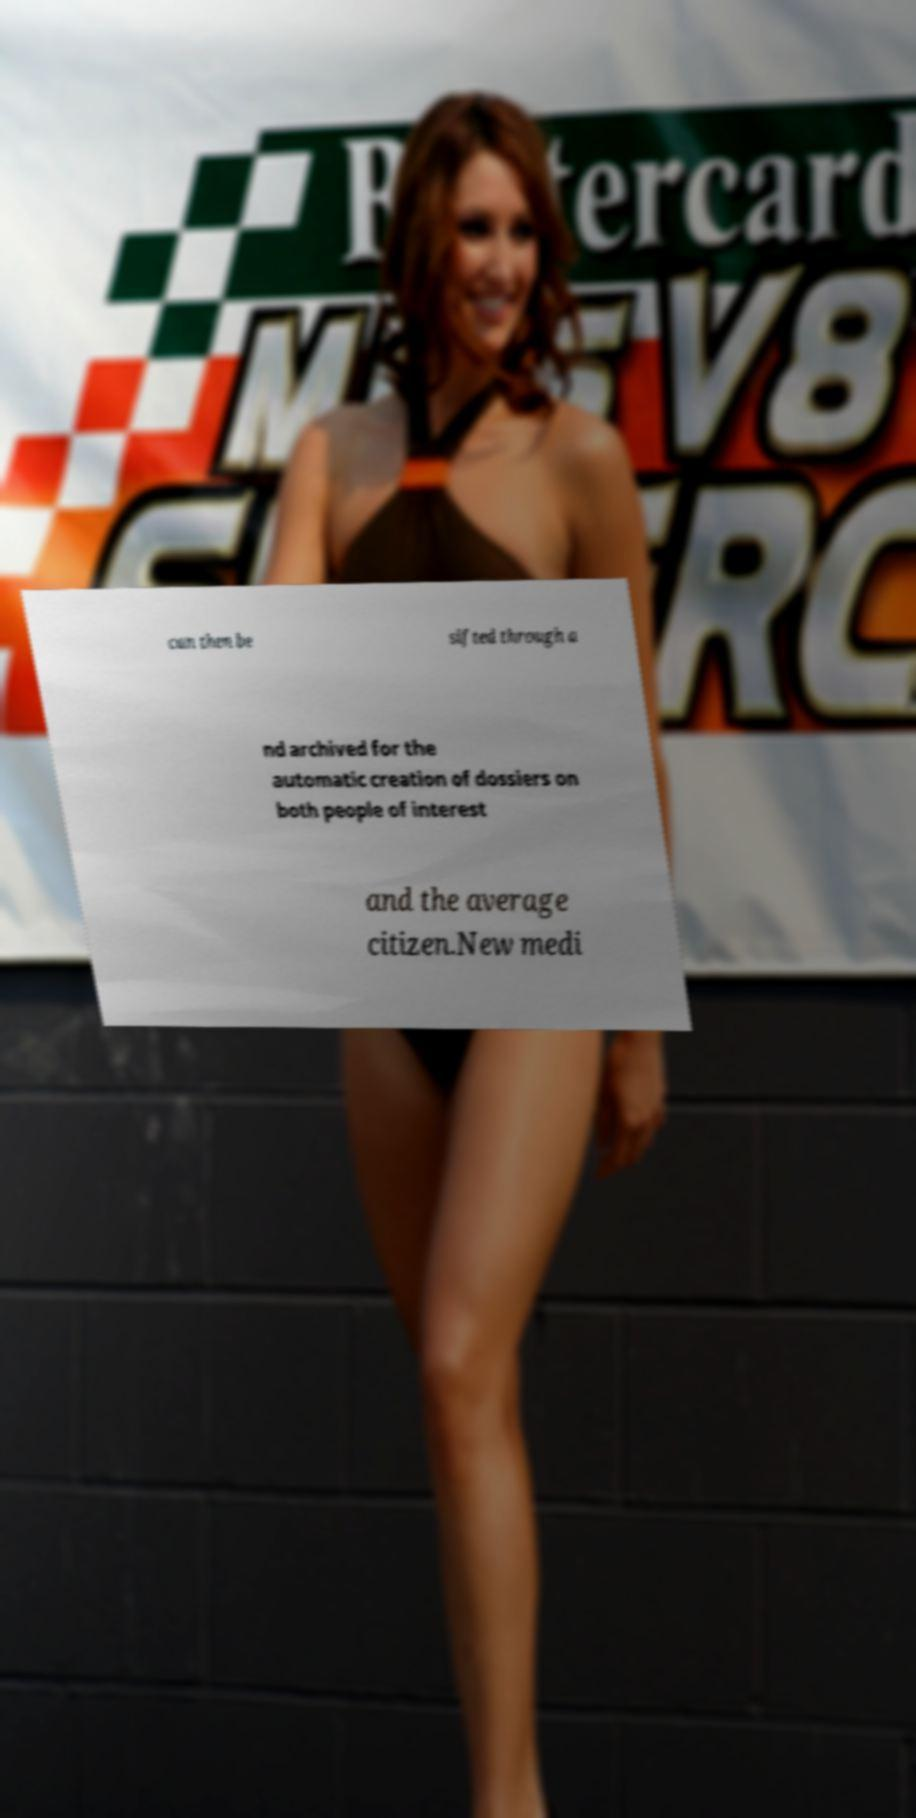Could you extract and type out the text from this image? can then be sifted through a nd archived for the automatic creation of dossiers on both people of interest and the average citizen.New medi 